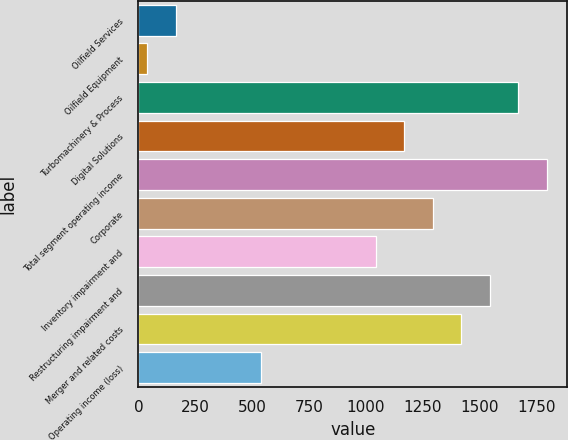<chart> <loc_0><loc_0><loc_500><loc_500><bar_chart><fcel>Oilfield Services<fcel>Oilfield Equipment<fcel>Turbomachinery & Process<fcel>Digital Solutions<fcel>Total segment operating income<fcel>Corporate<fcel>Inventory impairment and<fcel>Restructuring impairment and<fcel>Merger and related costs<fcel>Operating income (loss)<nl><fcel>163.7<fcel>38<fcel>1672.1<fcel>1169.3<fcel>1797.8<fcel>1295<fcel>1043.6<fcel>1546.4<fcel>1420.7<fcel>540.8<nl></chart> 